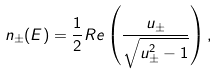Convert formula to latex. <formula><loc_0><loc_0><loc_500><loc_500>n _ { \pm } ( E ) = \frac { 1 } { 2 } R e \left ( \frac { u _ { \pm } } { \sqrt { u _ { \pm } ^ { 2 } - 1 } } \right ) ,</formula> 